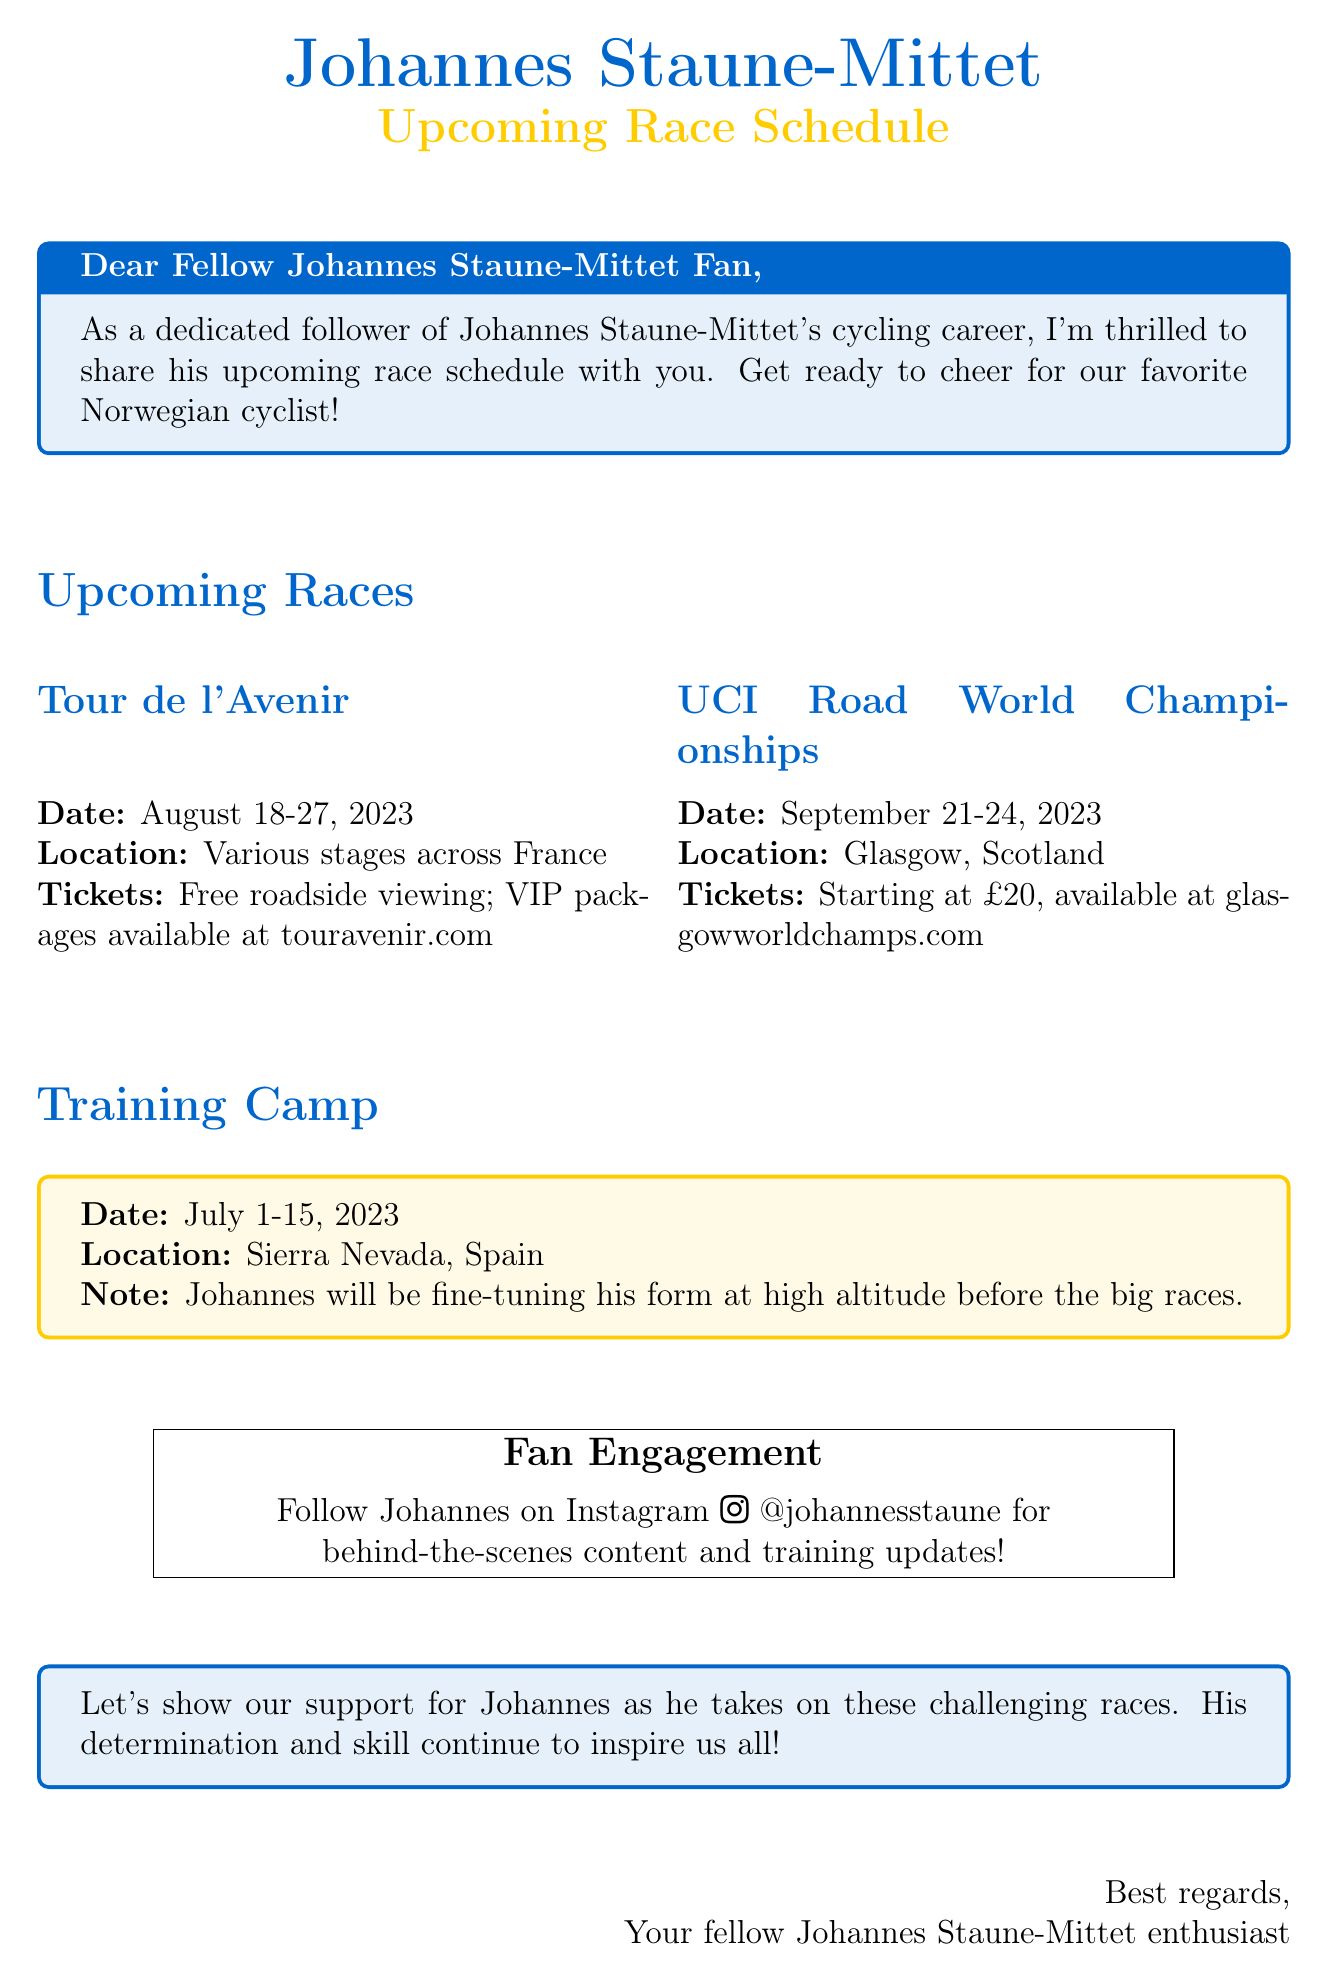What is the subject of the email? The subject line of the email provides an overview of its content, which is about Johannes Staune-Mittet's upcoming race schedule.
Answer: Exciting Update: Johannes Staune-Mittet's Upcoming Race Schedule! When will the Tour de l'Avenir take place? The date for the Tour de l'Avenir is listed in the upcoming races section of the document.
Answer: August 18-27, 2023 Where is the UCI Road World Championships being held? The location for the UCI Road World Championships is specified in the upcoming races section.
Answer: Glasgow, Scotland What is the ticket price for the UCI Road World Championships? The ticket information for the UCI Road World Championships provides the starting price details.
Answer: £20 What note is mentioned regarding the training camp? The note in the training camp section explains Johannes' purpose for attending the camp.
Answer: Johannes will be fine-tuning his form at high altitude before the big races What social media platform can fans follow Johannes on? The email encourages fans to engage with Johannes through a specific social media platform mentioned in the fan engagement section.
Answer: Instagram 